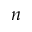Convert formula to latex. <formula><loc_0><loc_0><loc_500><loc_500>n</formula> 